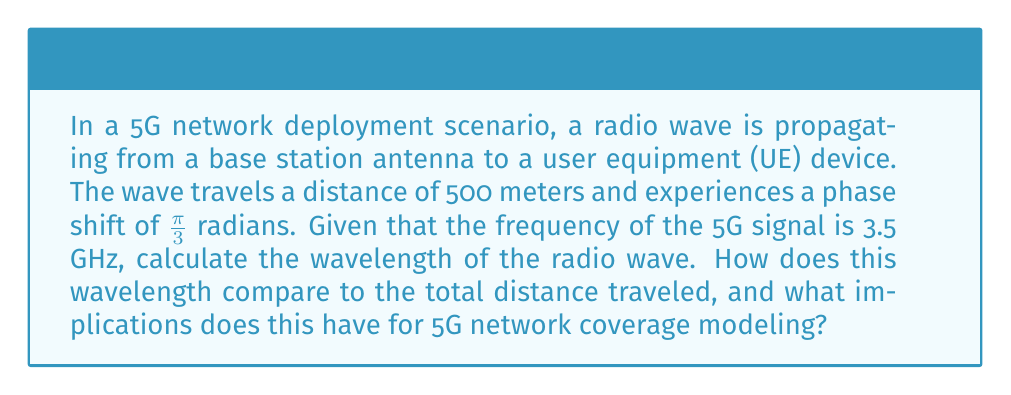Could you help me with this problem? Let's approach this step-by-step:

1) First, we need to recall the relationship between wavelength ($\lambda$), frequency ($f$), and the speed of light ($c$):

   $$c = f\lambda$$

2) We know that $c \approx 3 \times 10^8$ m/s and $f = 3.5$ GHz $= 3.5 \times 10^9$ Hz. Let's substitute these into the equation:

   $$3 \times 10^8 = (3.5 \times 10^9)\lambda$$

3) Solving for $\lambda$:

   $$\lambda = \frac{3 \times 10^8}{3.5 \times 10^9} = 0.0857 \text{ m} \approx 8.57 \text{ cm}$$

4) Now, let's consider the phase shift. The phase shift $\phi$ is related to the distance $d$ and wavelength $\lambda$ by:

   $$\phi = \frac{2\pi d}{\lambda}$$

5) We're given that $\phi = \frac{\pi}{3}$ and $d = 500$ m. Let's verify our wavelength calculation:

   $$\frac{\pi}{3} = \frac{2\pi (500)}{\lambda}$$

6) Solving for $\lambda$:

   $$\lambda = \frac{2\pi (500)}{\frac{\pi}{3}} = 3000 \text{ m}$$

7) This doesn't match our earlier calculation, indicating that the wave has completed multiple cycles. The actual distance is:

   $$500 \text{ m} + n\lambda, \text{ where } n \text{ is an integer}$$

8) To find $n$, we can divide 500 by our calculated wavelength:

   $$\frac{500}{0.0857} \approx 5834$$

This means the wave has completed about 5834 full cycles plus a fraction that gives us the $\frac{\pi}{3}$ phase shift.

Implications for 5G network coverage modeling:
1) The short wavelength (8.57 cm) compared to the total distance (500 m) means that small changes in distance can significantly affect the phase of the received signal.
2) This sensitivity to distance can be leveraged for accurate positioning in 5G networks.
3) However, it also means that small obstacles can cause significant signal attenuation, requiring more complex models for urban environments.
4) The high number of wavelengths in typical transmission distances necessitates considering multipath effects in coverage models.
Answer: $\lambda \approx 8.57 \text{ cm}$ 